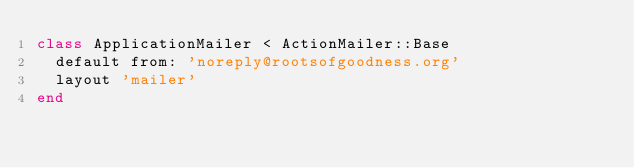<code> <loc_0><loc_0><loc_500><loc_500><_Ruby_>class ApplicationMailer < ActionMailer::Base
  default from: 'noreply@rootsofgoodness.org'
  layout 'mailer'
end

</code> 